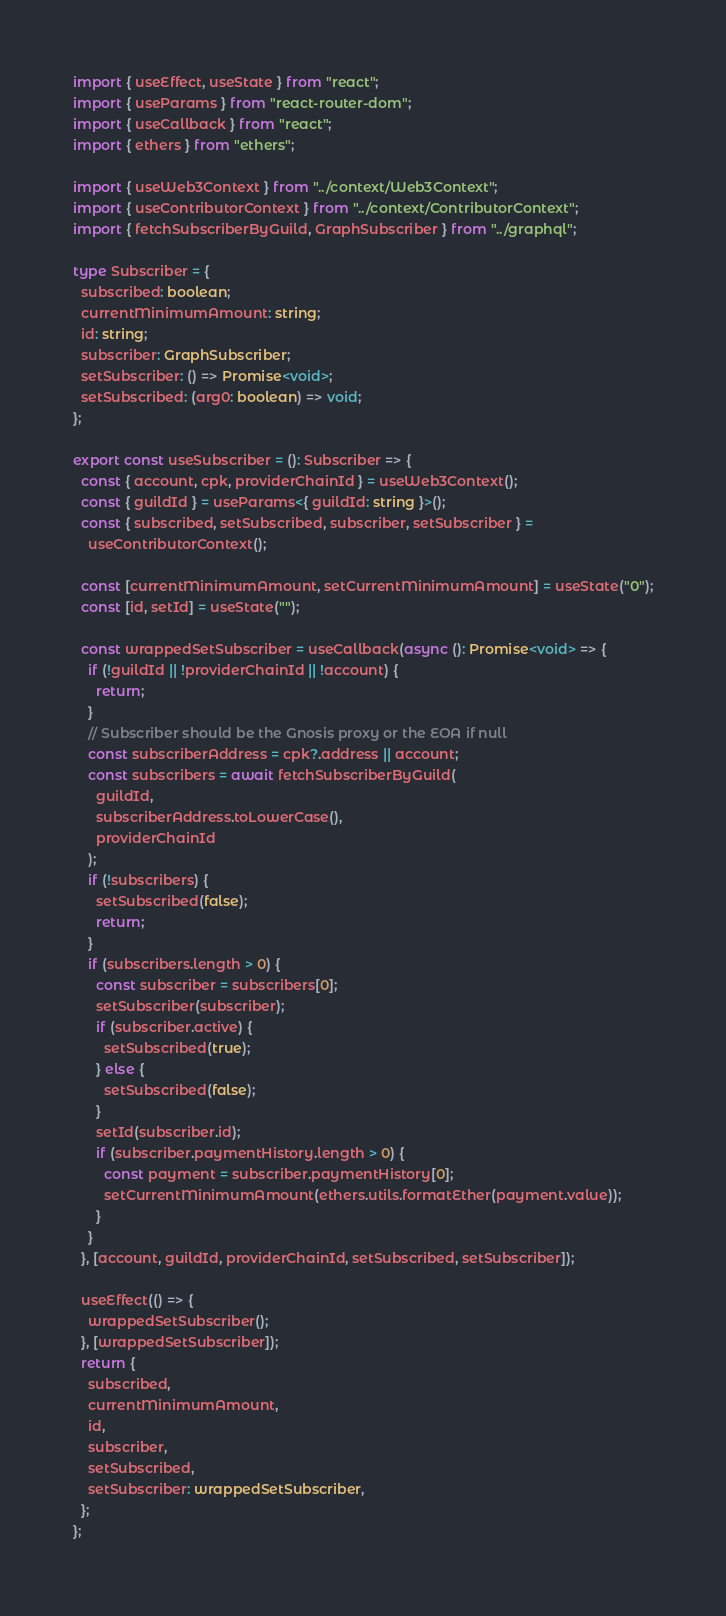Convert code to text. <code><loc_0><loc_0><loc_500><loc_500><_TypeScript_>import { useEffect, useState } from "react";
import { useParams } from "react-router-dom";
import { useCallback } from "react";
import { ethers } from "ethers";

import { useWeb3Context } from "../context/Web3Context";
import { useContributorContext } from "../context/ContributorContext";
import { fetchSubscriberByGuild, GraphSubscriber } from "../graphql";

type Subscriber = {
  subscribed: boolean;
  currentMinimumAmount: string;
  id: string;
  subscriber: GraphSubscriber;
  setSubscriber: () => Promise<void>;
  setSubscribed: (arg0: boolean) => void;
};

export const useSubscriber = (): Subscriber => {
  const { account, cpk, providerChainId } = useWeb3Context();
  const { guildId } = useParams<{ guildId: string }>();
  const { subscribed, setSubscribed, subscriber, setSubscriber } =
    useContributorContext();

  const [currentMinimumAmount, setCurrentMinimumAmount] = useState("0");
  const [id, setId] = useState("");

  const wrappedSetSubscriber = useCallback(async (): Promise<void> => {
    if (!guildId || !providerChainId || !account) {
      return;
    }
    // Subscriber should be the Gnosis proxy or the EOA if null
    const subscriberAddress = cpk?.address || account;
    const subscribers = await fetchSubscriberByGuild(
      guildId,
      subscriberAddress.toLowerCase(),
      providerChainId
    );
    if (!subscribers) {
      setSubscribed(false);
      return;
    }
    if (subscribers.length > 0) {
      const subscriber = subscribers[0];
      setSubscriber(subscriber);
      if (subscriber.active) {
        setSubscribed(true);
      } else {
        setSubscribed(false);
      }
      setId(subscriber.id);
      if (subscriber.paymentHistory.length > 0) {
        const payment = subscriber.paymentHistory[0];
        setCurrentMinimumAmount(ethers.utils.formatEther(payment.value));
      }
    }
  }, [account, guildId, providerChainId, setSubscribed, setSubscriber]);

  useEffect(() => {
    wrappedSetSubscriber();
  }, [wrappedSetSubscriber]);
  return {
    subscribed,
    currentMinimumAmount,
    id,
    subscriber,
    setSubscribed,
    setSubscriber: wrappedSetSubscriber,
  };
};
</code> 